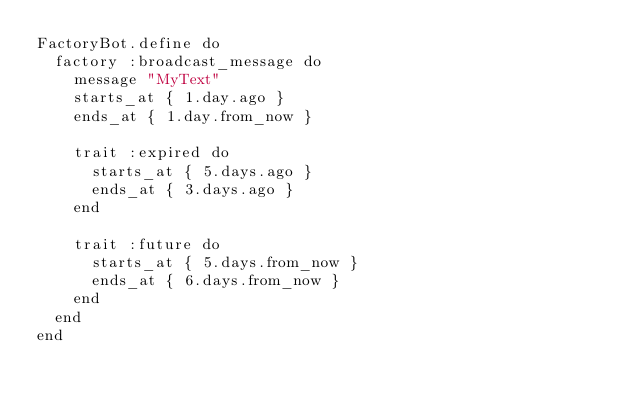Convert code to text. <code><loc_0><loc_0><loc_500><loc_500><_Ruby_>FactoryBot.define do
  factory :broadcast_message do
    message "MyText"
    starts_at { 1.day.ago }
    ends_at { 1.day.from_now }

    trait :expired do
      starts_at { 5.days.ago }
      ends_at { 3.days.ago }
    end

    trait :future do
      starts_at { 5.days.from_now }
      ends_at { 6.days.from_now }
    end
  end
end
</code> 